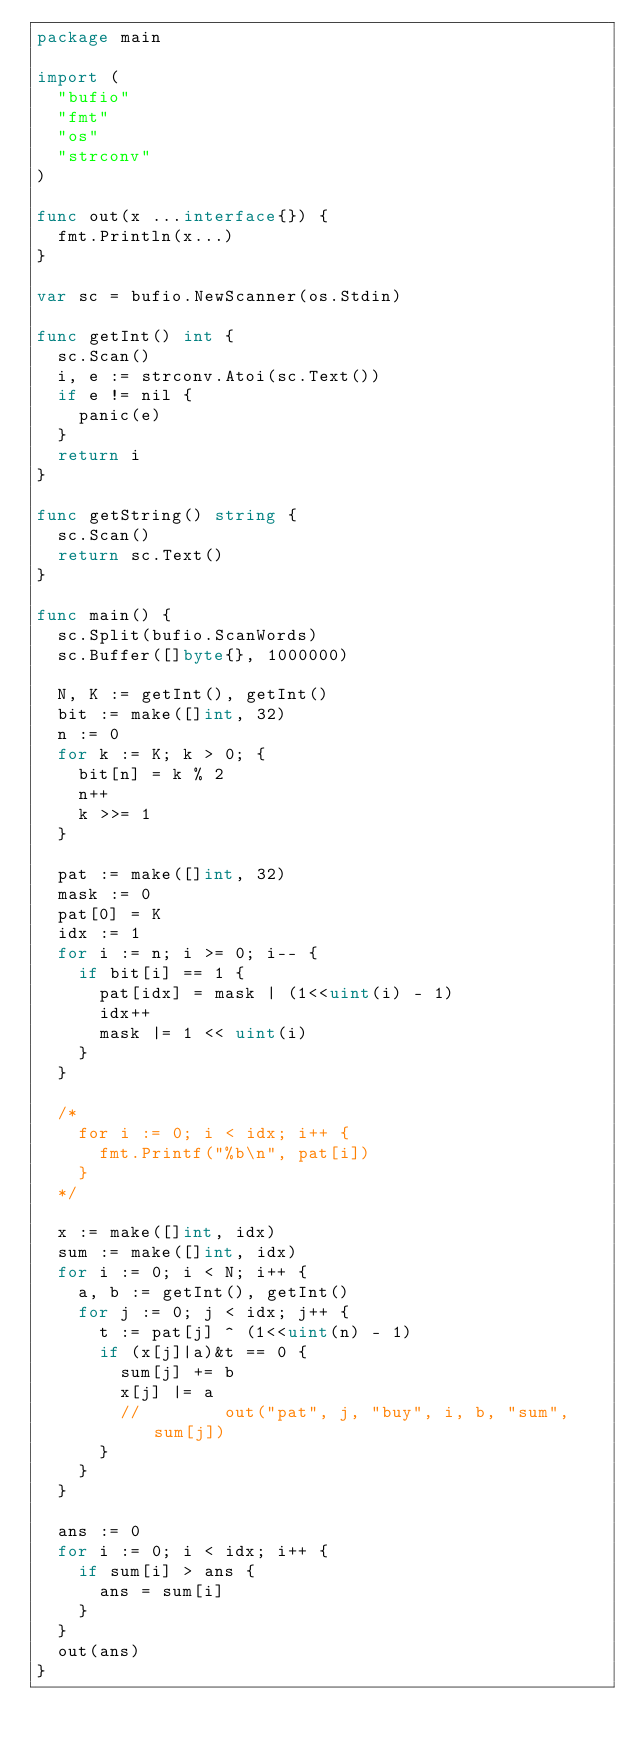Convert code to text. <code><loc_0><loc_0><loc_500><loc_500><_Go_>package main

import (
	"bufio"
	"fmt"
	"os"
	"strconv"
)

func out(x ...interface{}) {
	fmt.Println(x...)
}

var sc = bufio.NewScanner(os.Stdin)

func getInt() int {
	sc.Scan()
	i, e := strconv.Atoi(sc.Text())
	if e != nil {
		panic(e)
	}
	return i
}

func getString() string {
	sc.Scan()
	return sc.Text()
}

func main() {
	sc.Split(bufio.ScanWords)
	sc.Buffer([]byte{}, 1000000)

	N, K := getInt(), getInt()
	bit := make([]int, 32)
	n := 0
	for k := K; k > 0; {
		bit[n] = k % 2
		n++
		k >>= 1
	}

	pat := make([]int, 32)
	mask := 0
	pat[0] = K
	idx := 1
	for i := n; i >= 0; i-- {
		if bit[i] == 1 {
			pat[idx] = mask | (1<<uint(i) - 1)
			idx++
			mask |= 1 << uint(i)
		}
	}

	/*
		for i := 0; i < idx; i++ {
			fmt.Printf("%b\n", pat[i])
		}
	*/

	x := make([]int, idx)
	sum := make([]int, idx)
	for i := 0; i < N; i++ {
		a, b := getInt(), getInt()
		for j := 0; j < idx; j++ {
			t := pat[j] ^ (1<<uint(n) - 1)
			if (x[j]|a)&t == 0 {
				sum[j] += b
				x[j] |= a
				//				out("pat", j, "buy", i, b, "sum", sum[j])
			}
		}
	}

	ans := 0
	for i := 0; i < idx; i++ {
		if sum[i] > ans {
			ans = sum[i]
		}
	}
	out(ans)
}
</code> 